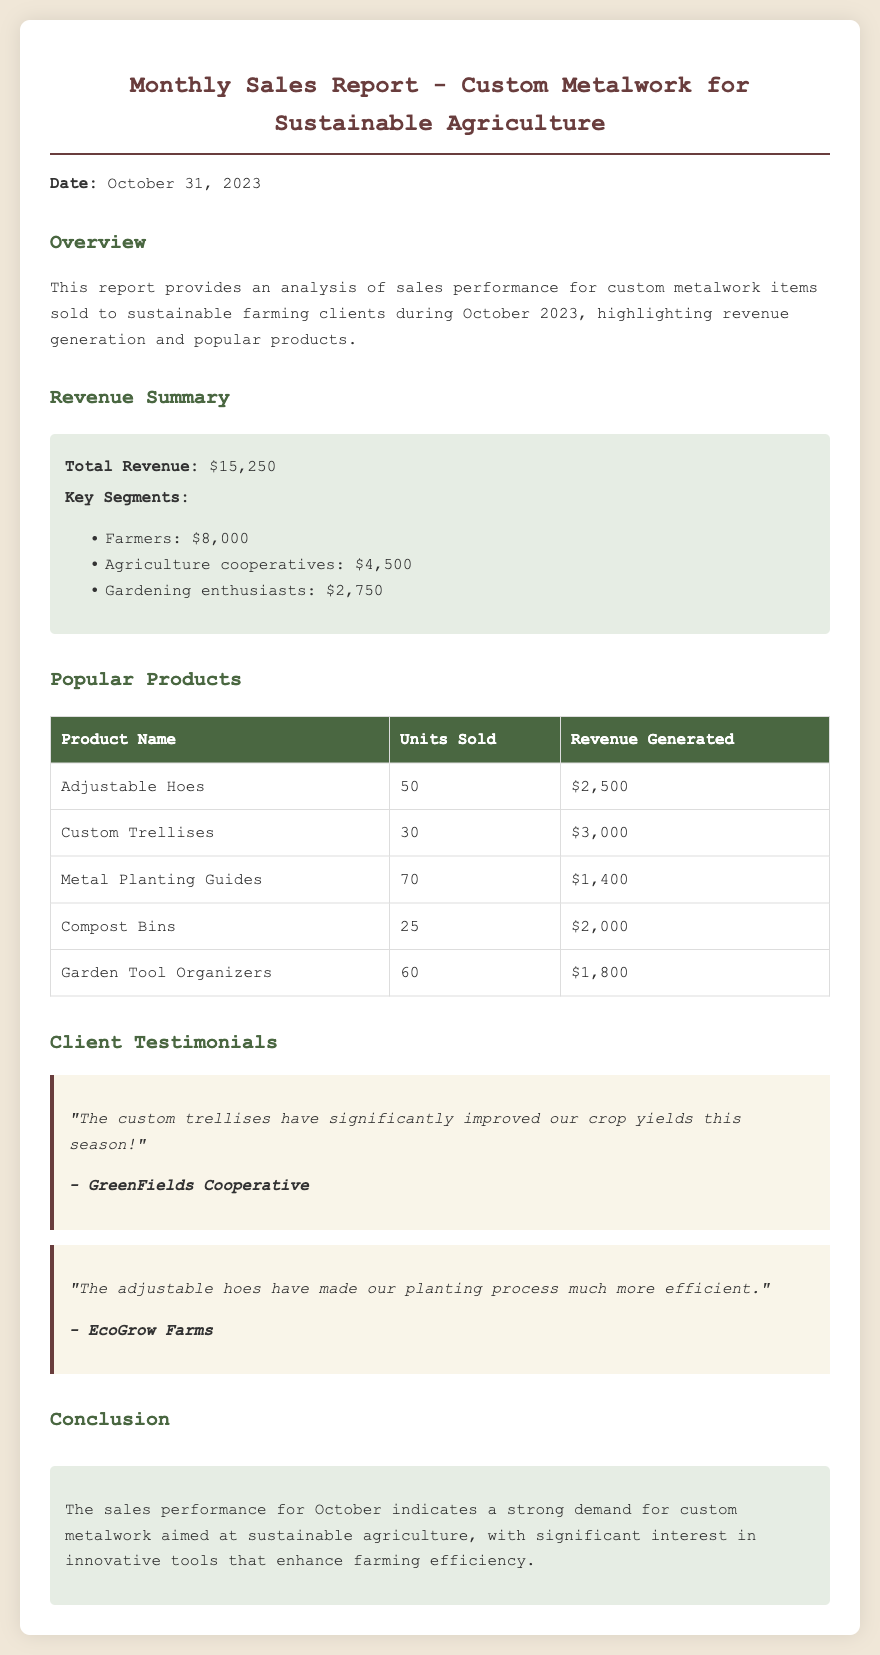What is the total revenue? The total revenue is explicitly stated in the report as $15,250.
Answer: $15,250 Which product generated the highest revenue? By comparing the revenue figures for all products listed, Custom Trellises generated the highest revenue at $3,000.
Answer: Custom Trellises How many units of Adjustable Hoes were sold? The number of units sold for Adjustable Hoes is presented as 50 in the popular products table.
Answer: 50 Which segment contributed the least to the total revenue? By analyzing the key segments provided, Gardening enthusiasts contributed the least amount of $2,750.
Answer: Gardening enthusiasts What date is the report dated? The report date is given as October 31, 2023, as noted in the introduction.
Answer: October 31, 2023 How many Compost Bins were sold? The report includes the figure of 25 units sold for Compost Bins.
Answer: 25 What is the testimonial from EcoGrow Farms about? The testimonial section specifies that EcoGrow Farms praised the adjustable hoes for improving planting efficiency.
Answer: Adjustable hoes How much revenue was generated from Agriculture cooperatives? The document states that Agriculture cooperatives generated $4,500 in revenue.
Answer: $4,500 